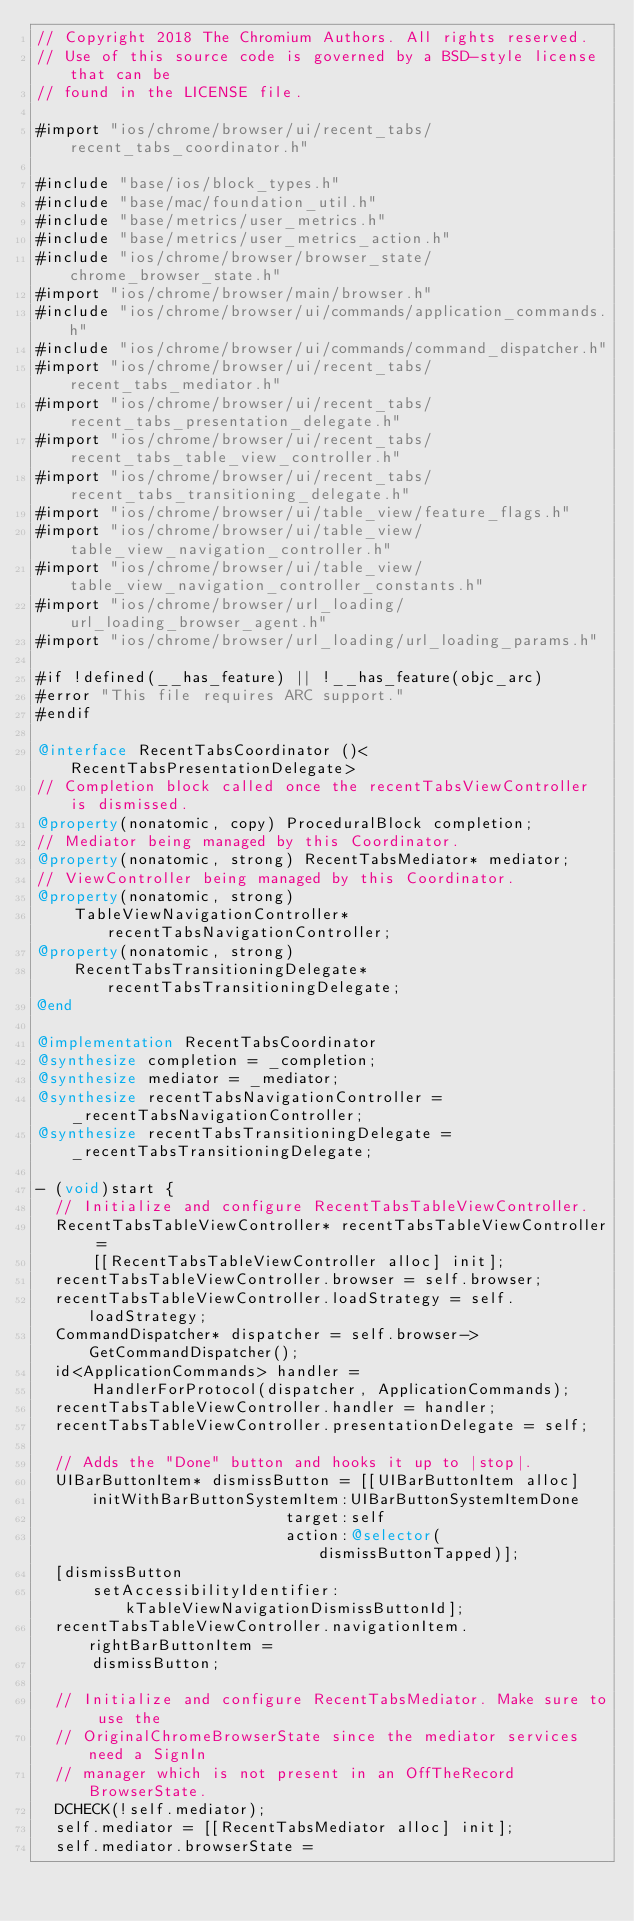Convert code to text. <code><loc_0><loc_0><loc_500><loc_500><_ObjectiveC_>// Copyright 2018 The Chromium Authors. All rights reserved.
// Use of this source code is governed by a BSD-style license that can be
// found in the LICENSE file.

#import "ios/chrome/browser/ui/recent_tabs/recent_tabs_coordinator.h"

#include "base/ios/block_types.h"
#include "base/mac/foundation_util.h"
#include "base/metrics/user_metrics.h"
#include "base/metrics/user_metrics_action.h"
#include "ios/chrome/browser/browser_state/chrome_browser_state.h"
#import "ios/chrome/browser/main/browser.h"
#include "ios/chrome/browser/ui/commands/application_commands.h"
#include "ios/chrome/browser/ui/commands/command_dispatcher.h"
#import "ios/chrome/browser/ui/recent_tabs/recent_tabs_mediator.h"
#import "ios/chrome/browser/ui/recent_tabs/recent_tabs_presentation_delegate.h"
#import "ios/chrome/browser/ui/recent_tabs/recent_tabs_table_view_controller.h"
#import "ios/chrome/browser/ui/recent_tabs/recent_tabs_transitioning_delegate.h"
#import "ios/chrome/browser/ui/table_view/feature_flags.h"
#import "ios/chrome/browser/ui/table_view/table_view_navigation_controller.h"
#import "ios/chrome/browser/ui/table_view/table_view_navigation_controller_constants.h"
#import "ios/chrome/browser/url_loading/url_loading_browser_agent.h"
#import "ios/chrome/browser/url_loading/url_loading_params.h"

#if !defined(__has_feature) || !__has_feature(objc_arc)
#error "This file requires ARC support."
#endif

@interface RecentTabsCoordinator ()<RecentTabsPresentationDelegate>
// Completion block called once the recentTabsViewController is dismissed.
@property(nonatomic, copy) ProceduralBlock completion;
// Mediator being managed by this Coordinator.
@property(nonatomic, strong) RecentTabsMediator* mediator;
// ViewController being managed by this Coordinator.
@property(nonatomic, strong)
    TableViewNavigationController* recentTabsNavigationController;
@property(nonatomic, strong)
    RecentTabsTransitioningDelegate* recentTabsTransitioningDelegate;
@end

@implementation RecentTabsCoordinator
@synthesize completion = _completion;
@synthesize mediator = _mediator;
@synthesize recentTabsNavigationController = _recentTabsNavigationController;
@synthesize recentTabsTransitioningDelegate = _recentTabsTransitioningDelegate;

- (void)start {
  // Initialize and configure RecentTabsTableViewController.
  RecentTabsTableViewController* recentTabsTableViewController =
      [[RecentTabsTableViewController alloc] init];
  recentTabsTableViewController.browser = self.browser;
  recentTabsTableViewController.loadStrategy = self.loadStrategy;
  CommandDispatcher* dispatcher = self.browser->GetCommandDispatcher();
  id<ApplicationCommands> handler =
      HandlerForProtocol(dispatcher, ApplicationCommands);
  recentTabsTableViewController.handler = handler;
  recentTabsTableViewController.presentationDelegate = self;

  // Adds the "Done" button and hooks it up to |stop|.
  UIBarButtonItem* dismissButton = [[UIBarButtonItem alloc]
      initWithBarButtonSystemItem:UIBarButtonSystemItemDone
                           target:self
                           action:@selector(dismissButtonTapped)];
  [dismissButton
      setAccessibilityIdentifier:kTableViewNavigationDismissButtonId];
  recentTabsTableViewController.navigationItem.rightBarButtonItem =
      dismissButton;

  // Initialize and configure RecentTabsMediator. Make sure to use the
  // OriginalChromeBrowserState since the mediator services need a SignIn
  // manager which is not present in an OffTheRecord BrowserState.
  DCHECK(!self.mediator);
  self.mediator = [[RecentTabsMediator alloc] init];
  self.mediator.browserState =</code> 